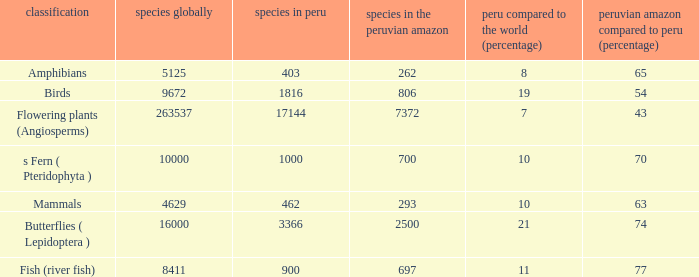What's the maximum peru vs. world (percent) with 9672 species in the world  19.0. 